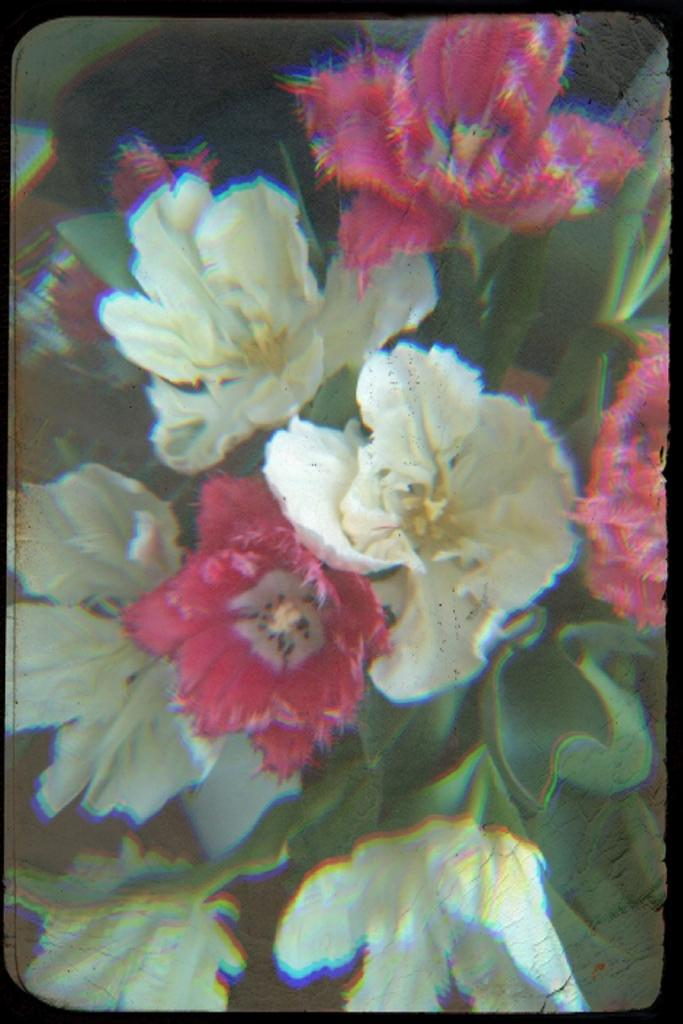What type of living organisms can be seen in the image? Plants can be seen in the image. What colors are the flowers on the plants? The flowers on the plants have white and pink colors. What color are the leaves on the plants? The leaves on the plants are green. How would you describe the background of the image? The background of the image is blurred. What type of creature is celebrating its birthday in the image? There is no creature or birthday celebration present in the image; it features plants with flowers and leaves. 